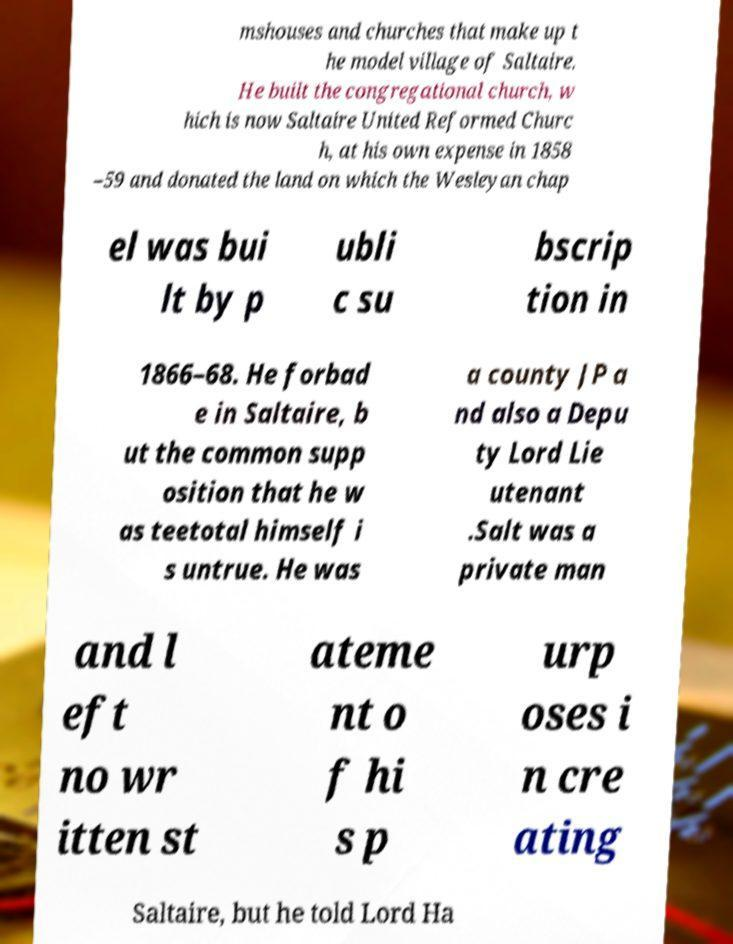Can you accurately transcribe the text from the provided image for me? mshouses and churches that make up t he model village of Saltaire. He built the congregational church, w hich is now Saltaire United Reformed Churc h, at his own expense in 1858 –59 and donated the land on which the Wesleyan chap el was bui lt by p ubli c su bscrip tion in 1866–68. He forbad e in Saltaire, b ut the common supp osition that he w as teetotal himself i s untrue. He was a county JP a nd also a Depu ty Lord Lie utenant .Salt was a private man and l eft no wr itten st ateme nt o f hi s p urp oses i n cre ating Saltaire, but he told Lord Ha 